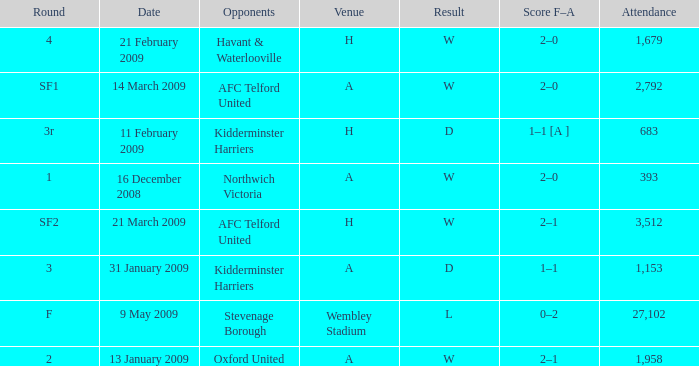What is the round on 21 february 2009? 4.0. 